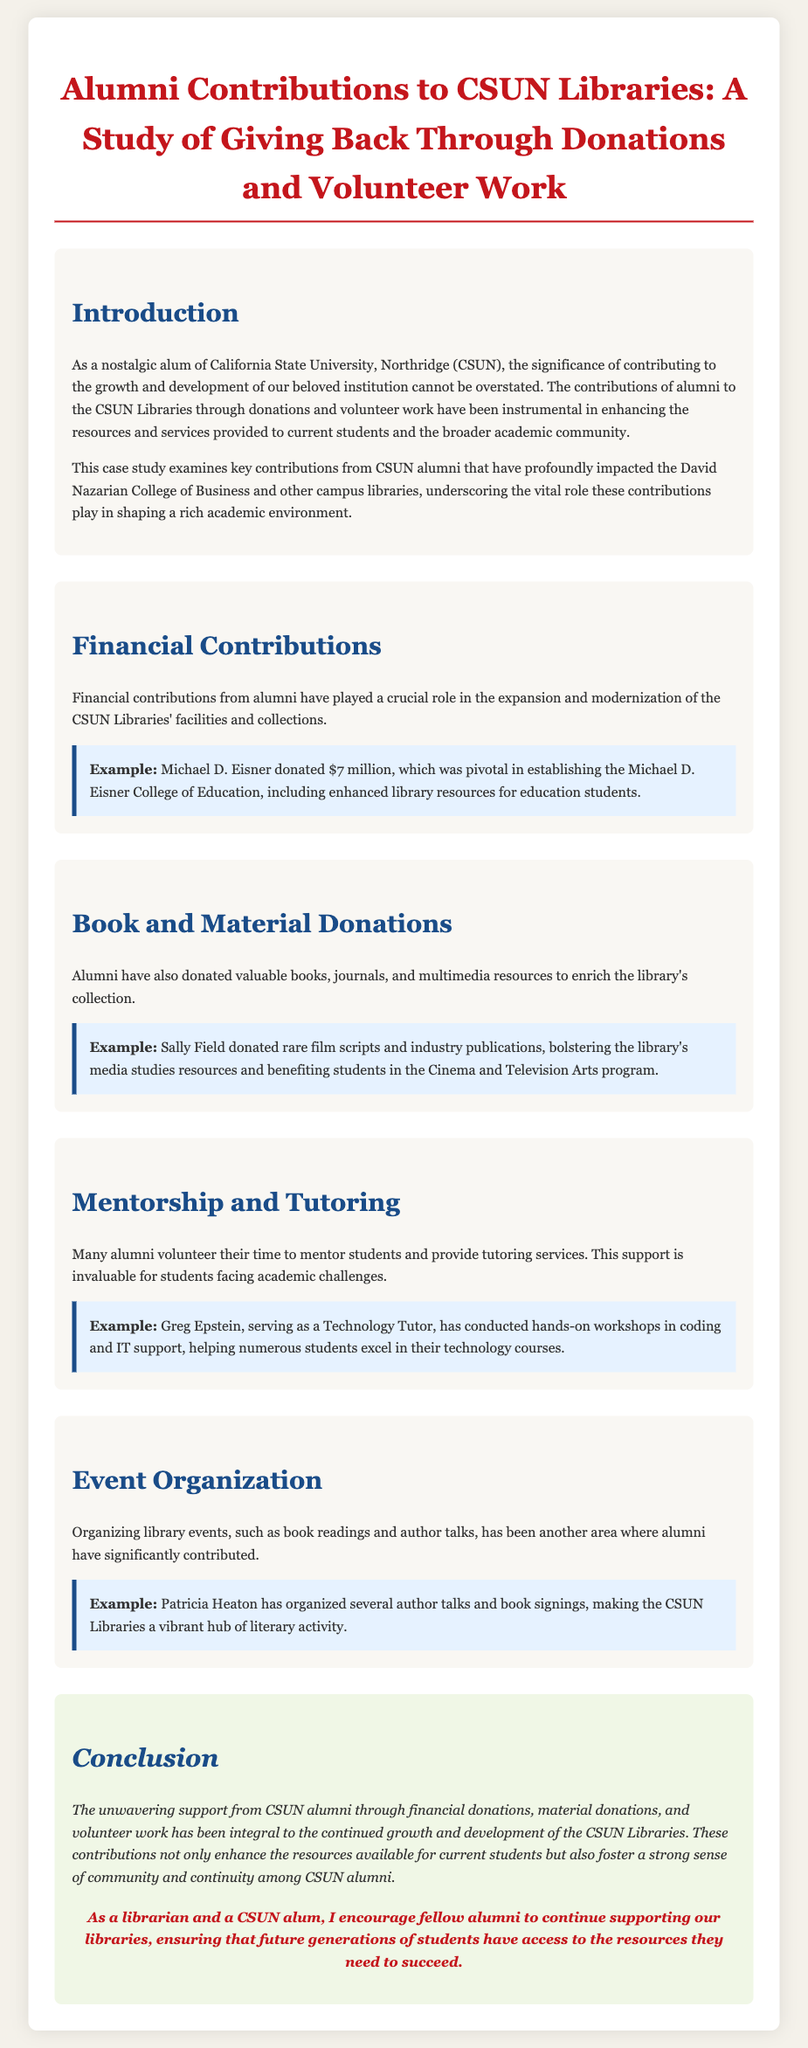What is the title of the case study? The title is the main heading of the document that reflects its focus on alumni contributions to libraries.
Answer: Alumni Contributions to CSUN Libraries: A Study of Giving Back Through Donations and Volunteer Work Who donated $7 million? The document provides specific examples of alumni contributions, including financial donations from notable individuals.
Answer: Michael D. Eisner What types of donations have alumni made to the CSUN Libraries? The document outlines various forms of contributions made by alumni, highlighting different categories of support.
Answer: Books, journals, and multimedia resources What role did Greg Epstein play in supporting students? This question asks for a specific function that an alumni member serves, based on his volunteer work mentioned in the document.
Answer: Technology Tutor Which alumnus organized author talks at the CSUN Libraries? The question focuses on identifying a particular individual from the volunteer efforts highlighted in the case study.
Answer: Patricia Heaton How have alumni contributions impacted current students? This question requires reasoning about the general effects of alumni contributions as described in the conclusion.
Answer: Enhanced resources available What is the main theme of the conclusion? The conclusion summarizes the overall findings and emphasizes a recurring idea related to alumni contributions throughout the document.
Answer: Continued growth and development In which library is the Michael D. Eisner donation significant? This question requires identification of the specific educational entity supported by the notable donation.
Answer: Michael D. Eisner College of Education 